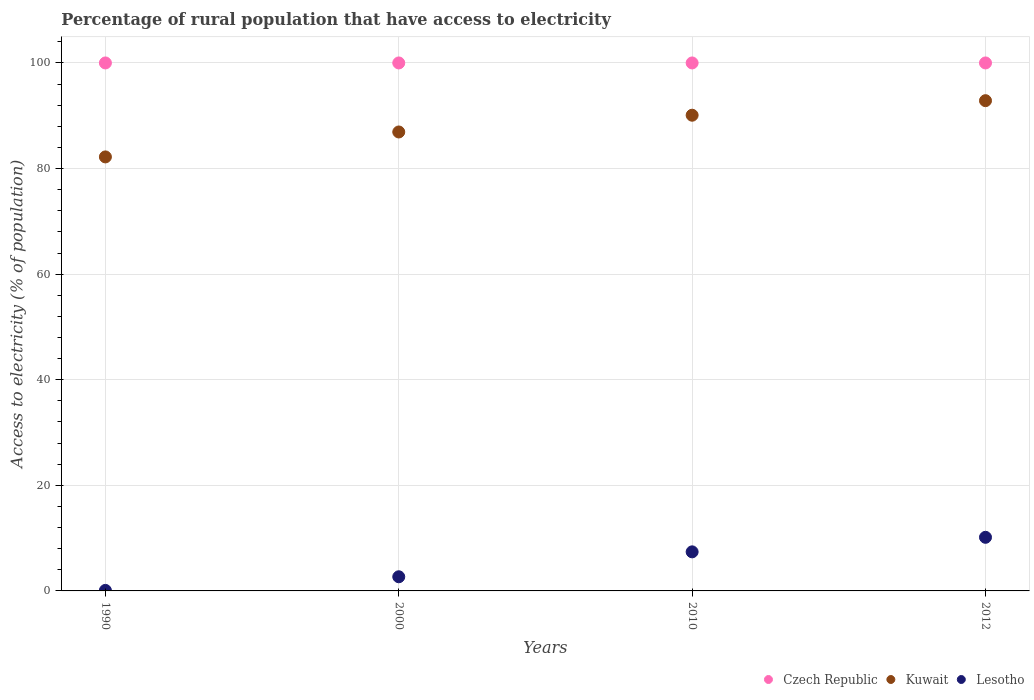How many different coloured dotlines are there?
Ensure brevity in your answer.  3. Is the number of dotlines equal to the number of legend labels?
Your answer should be compact. Yes. What is the percentage of rural population that have access to electricity in Lesotho in 2010?
Give a very brief answer. 7.4. Across all years, what is the maximum percentage of rural population that have access to electricity in Czech Republic?
Offer a terse response. 100. Across all years, what is the minimum percentage of rural population that have access to electricity in Kuwait?
Your answer should be compact. 82.2. What is the total percentage of rural population that have access to electricity in Kuwait in the graph?
Your answer should be very brief. 352.08. What is the difference between the percentage of rural population that have access to electricity in Lesotho in 2000 and that in 2012?
Offer a terse response. -7.47. What is the difference between the percentage of rural population that have access to electricity in Czech Republic in 1990 and the percentage of rural population that have access to electricity in Kuwait in 2012?
Your answer should be very brief. 7.15. What is the average percentage of rural population that have access to electricity in Czech Republic per year?
Your response must be concise. 100. In the year 2010, what is the difference between the percentage of rural population that have access to electricity in Czech Republic and percentage of rural population that have access to electricity in Lesotho?
Your answer should be compact. 92.6. In how many years, is the percentage of rural population that have access to electricity in Lesotho greater than 68 %?
Offer a very short reply. 0. What is the ratio of the percentage of rural population that have access to electricity in Czech Republic in 1990 to that in 2010?
Provide a short and direct response. 1. What is the difference between the highest and the second highest percentage of rural population that have access to electricity in Lesotho?
Give a very brief answer. 2.75. What is the difference between the highest and the lowest percentage of rural population that have access to electricity in Kuwait?
Make the answer very short. 10.65. In how many years, is the percentage of rural population that have access to electricity in Czech Republic greater than the average percentage of rural population that have access to electricity in Czech Republic taken over all years?
Your answer should be very brief. 0. Is the sum of the percentage of rural population that have access to electricity in Lesotho in 1990 and 2010 greater than the maximum percentage of rural population that have access to electricity in Kuwait across all years?
Offer a very short reply. No. Is it the case that in every year, the sum of the percentage of rural population that have access to electricity in Lesotho and percentage of rural population that have access to electricity in Kuwait  is greater than the percentage of rural population that have access to electricity in Czech Republic?
Keep it short and to the point. No. Is the percentage of rural population that have access to electricity in Lesotho strictly less than the percentage of rural population that have access to electricity in Kuwait over the years?
Offer a very short reply. Yes. How many years are there in the graph?
Provide a succinct answer. 4. What is the difference between two consecutive major ticks on the Y-axis?
Provide a succinct answer. 20. Are the values on the major ticks of Y-axis written in scientific E-notation?
Give a very brief answer. No. Does the graph contain any zero values?
Provide a succinct answer. No. How many legend labels are there?
Give a very brief answer. 3. How are the legend labels stacked?
Keep it short and to the point. Horizontal. What is the title of the graph?
Offer a terse response. Percentage of rural population that have access to electricity. What is the label or title of the Y-axis?
Provide a succinct answer. Access to electricity (% of population). What is the Access to electricity (% of population) in Kuwait in 1990?
Your response must be concise. 82.2. What is the Access to electricity (% of population) in Kuwait in 2000?
Your response must be concise. 86.93. What is the Access to electricity (% of population) of Lesotho in 2000?
Ensure brevity in your answer.  2.68. What is the Access to electricity (% of population) in Czech Republic in 2010?
Provide a short and direct response. 100. What is the Access to electricity (% of population) of Kuwait in 2010?
Provide a short and direct response. 90.1. What is the Access to electricity (% of population) of Lesotho in 2010?
Offer a terse response. 7.4. What is the Access to electricity (% of population) of Czech Republic in 2012?
Provide a short and direct response. 100. What is the Access to electricity (% of population) in Kuwait in 2012?
Provide a succinct answer. 92.85. What is the Access to electricity (% of population) in Lesotho in 2012?
Your answer should be very brief. 10.15. Across all years, what is the maximum Access to electricity (% of population) of Czech Republic?
Give a very brief answer. 100. Across all years, what is the maximum Access to electricity (% of population) in Kuwait?
Your answer should be compact. 92.85. Across all years, what is the maximum Access to electricity (% of population) of Lesotho?
Ensure brevity in your answer.  10.15. Across all years, what is the minimum Access to electricity (% of population) of Kuwait?
Your response must be concise. 82.2. What is the total Access to electricity (% of population) of Czech Republic in the graph?
Keep it short and to the point. 400. What is the total Access to electricity (% of population) in Kuwait in the graph?
Keep it short and to the point. 352.08. What is the total Access to electricity (% of population) of Lesotho in the graph?
Your answer should be compact. 20.34. What is the difference between the Access to electricity (% of population) of Kuwait in 1990 and that in 2000?
Your response must be concise. -4.72. What is the difference between the Access to electricity (% of population) of Lesotho in 1990 and that in 2000?
Make the answer very short. -2.58. What is the difference between the Access to electricity (% of population) in Kuwait in 1990 and that in 2010?
Give a very brief answer. -7.9. What is the difference between the Access to electricity (% of population) in Czech Republic in 1990 and that in 2012?
Your answer should be compact. 0. What is the difference between the Access to electricity (% of population) of Kuwait in 1990 and that in 2012?
Your answer should be compact. -10.65. What is the difference between the Access to electricity (% of population) of Lesotho in 1990 and that in 2012?
Offer a very short reply. -10.05. What is the difference between the Access to electricity (% of population) in Kuwait in 2000 and that in 2010?
Give a very brief answer. -3.17. What is the difference between the Access to electricity (% of population) of Lesotho in 2000 and that in 2010?
Offer a terse response. -4.72. What is the difference between the Access to electricity (% of population) in Czech Republic in 2000 and that in 2012?
Provide a succinct answer. 0. What is the difference between the Access to electricity (% of population) in Kuwait in 2000 and that in 2012?
Provide a succinct answer. -5.93. What is the difference between the Access to electricity (% of population) in Lesotho in 2000 and that in 2012?
Give a very brief answer. -7.47. What is the difference between the Access to electricity (% of population) of Czech Republic in 2010 and that in 2012?
Ensure brevity in your answer.  0. What is the difference between the Access to electricity (% of population) of Kuwait in 2010 and that in 2012?
Give a very brief answer. -2.75. What is the difference between the Access to electricity (% of population) in Lesotho in 2010 and that in 2012?
Offer a terse response. -2.75. What is the difference between the Access to electricity (% of population) of Czech Republic in 1990 and the Access to electricity (% of population) of Kuwait in 2000?
Your answer should be compact. 13.07. What is the difference between the Access to electricity (% of population) in Czech Republic in 1990 and the Access to electricity (% of population) in Lesotho in 2000?
Offer a terse response. 97.32. What is the difference between the Access to electricity (% of population) in Kuwait in 1990 and the Access to electricity (% of population) in Lesotho in 2000?
Provide a short and direct response. 79.52. What is the difference between the Access to electricity (% of population) in Czech Republic in 1990 and the Access to electricity (% of population) in Kuwait in 2010?
Offer a terse response. 9.9. What is the difference between the Access to electricity (% of population) in Czech Republic in 1990 and the Access to electricity (% of population) in Lesotho in 2010?
Provide a short and direct response. 92.6. What is the difference between the Access to electricity (% of population) in Kuwait in 1990 and the Access to electricity (% of population) in Lesotho in 2010?
Provide a short and direct response. 74.8. What is the difference between the Access to electricity (% of population) of Czech Republic in 1990 and the Access to electricity (% of population) of Kuwait in 2012?
Provide a succinct answer. 7.15. What is the difference between the Access to electricity (% of population) of Czech Republic in 1990 and the Access to electricity (% of population) of Lesotho in 2012?
Your answer should be compact. 89.85. What is the difference between the Access to electricity (% of population) of Kuwait in 1990 and the Access to electricity (% of population) of Lesotho in 2012?
Your answer should be very brief. 72.05. What is the difference between the Access to electricity (% of population) in Czech Republic in 2000 and the Access to electricity (% of population) in Kuwait in 2010?
Provide a short and direct response. 9.9. What is the difference between the Access to electricity (% of population) in Czech Republic in 2000 and the Access to electricity (% of population) in Lesotho in 2010?
Make the answer very short. 92.6. What is the difference between the Access to electricity (% of population) in Kuwait in 2000 and the Access to electricity (% of population) in Lesotho in 2010?
Make the answer very short. 79.53. What is the difference between the Access to electricity (% of population) of Czech Republic in 2000 and the Access to electricity (% of population) of Kuwait in 2012?
Offer a very short reply. 7.15. What is the difference between the Access to electricity (% of population) in Czech Republic in 2000 and the Access to electricity (% of population) in Lesotho in 2012?
Offer a very short reply. 89.85. What is the difference between the Access to electricity (% of population) of Kuwait in 2000 and the Access to electricity (% of population) of Lesotho in 2012?
Provide a succinct answer. 76.77. What is the difference between the Access to electricity (% of population) of Czech Republic in 2010 and the Access to electricity (% of population) of Kuwait in 2012?
Make the answer very short. 7.15. What is the difference between the Access to electricity (% of population) in Czech Republic in 2010 and the Access to electricity (% of population) in Lesotho in 2012?
Make the answer very short. 89.85. What is the difference between the Access to electricity (% of population) of Kuwait in 2010 and the Access to electricity (% of population) of Lesotho in 2012?
Make the answer very short. 79.95. What is the average Access to electricity (% of population) in Kuwait per year?
Ensure brevity in your answer.  88.02. What is the average Access to electricity (% of population) of Lesotho per year?
Ensure brevity in your answer.  5.08. In the year 1990, what is the difference between the Access to electricity (% of population) of Czech Republic and Access to electricity (% of population) of Kuwait?
Keep it short and to the point. 17.8. In the year 1990, what is the difference between the Access to electricity (% of population) in Czech Republic and Access to electricity (% of population) in Lesotho?
Your answer should be very brief. 99.9. In the year 1990, what is the difference between the Access to electricity (% of population) in Kuwait and Access to electricity (% of population) in Lesotho?
Your answer should be compact. 82.1. In the year 2000, what is the difference between the Access to electricity (% of population) in Czech Republic and Access to electricity (% of population) in Kuwait?
Your answer should be very brief. 13.07. In the year 2000, what is the difference between the Access to electricity (% of population) of Czech Republic and Access to electricity (% of population) of Lesotho?
Give a very brief answer. 97.32. In the year 2000, what is the difference between the Access to electricity (% of population) of Kuwait and Access to electricity (% of population) of Lesotho?
Your response must be concise. 84.25. In the year 2010, what is the difference between the Access to electricity (% of population) in Czech Republic and Access to electricity (% of population) in Lesotho?
Your response must be concise. 92.6. In the year 2010, what is the difference between the Access to electricity (% of population) of Kuwait and Access to electricity (% of population) of Lesotho?
Make the answer very short. 82.7. In the year 2012, what is the difference between the Access to electricity (% of population) in Czech Republic and Access to electricity (% of population) in Kuwait?
Offer a terse response. 7.15. In the year 2012, what is the difference between the Access to electricity (% of population) of Czech Republic and Access to electricity (% of population) of Lesotho?
Your response must be concise. 89.85. In the year 2012, what is the difference between the Access to electricity (% of population) of Kuwait and Access to electricity (% of population) of Lesotho?
Offer a very short reply. 82.7. What is the ratio of the Access to electricity (% of population) of Czech Republic in 1990 to that in 2000?
Give a very brief answer. 1. What is the ratio of the Access to electricity (% of population) in Kuwait in 1990 to that in 2000?
Give a very brief answer. 0.95. What is the ratio of the Access to electricity (% of population) in Lesotho in 1990 to that in 2000?
Your response must be concise. 0.04. What is the ratio of the Access to electricity (% of population) of Czech Republic in 1990 to that in 2010?
Provide a short and direct response. 1. What is the ratio of the Access to electricity (% of population) of Kuwait in 1990 to that in 2010?
Offer a terse response. 0.91. What is the ratio of the Access to electricity (% of population) in Lesotho in 1990 to that in 2010?
Keep it short and to the point. 0.01. What is the ratio of the Access to electricity (% of population) of Kuwait in 1990 to that in 2012?
Ensure brevity in your answer.  0.89. What is the ratio of the Access to electricity (% of population) of Lesotho in 1990 to that in 2012?
Provide a succinct answer. 0.01. What is the ratio of the Access to electricity (% of population) of Czech Republic in 2000 to that in 2010?
Provide a succinct answer. 1. What is the ratio of the Access to electricity (% of population) of Kuwait in 2000 to that in 2010?
Offer a very short reply. 0.96. What is the ratio of the Access to electricity (% of population) of Lesotho in 2000 to that in 2010?
Offer a terse response. 0.36. What is the ratio of the Access to electricity (% of population) in Kuwait in 2000 to that in 2012?
Offer a very short reply. 0.94. What is the ratio of the Access to electricity (% of population) of Lesotho in 2000 to that in 2012?
Ensure brevity in your answer.  0.26. What is the ratio of the Access to electricity (% of population) of Kuwait in 2010 to that in 2012?
Your answer should be very brief. 0.97. What is the ratio of the Access to electricity (% of population) in Lesotho in 2010 to that in 2012?
Your answer should be compact. 0.73. What is the difference between the highest and the second highest Access to electricity (% of population) in Kuwait?
Ensure brevity in your answer.  2.75. What is the difference between the highest and the second highest Access to electricity (% of population) in Lesotho?
Your answer should be compact. 2.75. What is the difference between the highest and the lowest Access to electricity (% of population) of Kuwait?
Provide a short and direct response. 10.65. What is the difference between the highest and the lowest Access to electricity (% of population) of Lesotho?
Offer a terse response. 10.05. 